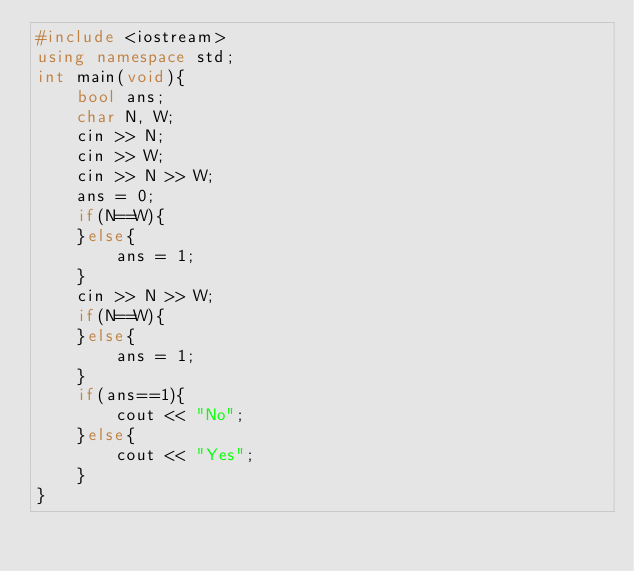<code> <loc_0><loc_0><loc_500><loc_500><_C++_>#include <iostream>
using namespace std;
int main(void){
    bool ans;
    char N, W;
    cin >> N;
    cin >> W; 
    cin >> N >> W;
    ans = 0;
    if(N==W){
    }else{
        ans = 1;
    }
    cin >> N >> W;
    if(N==W){
    }else{
        ans = 1;
    }
    if(ans==1){
        cout << "No";
    }else{
        cout << "Yes";
    }
}
</code> 